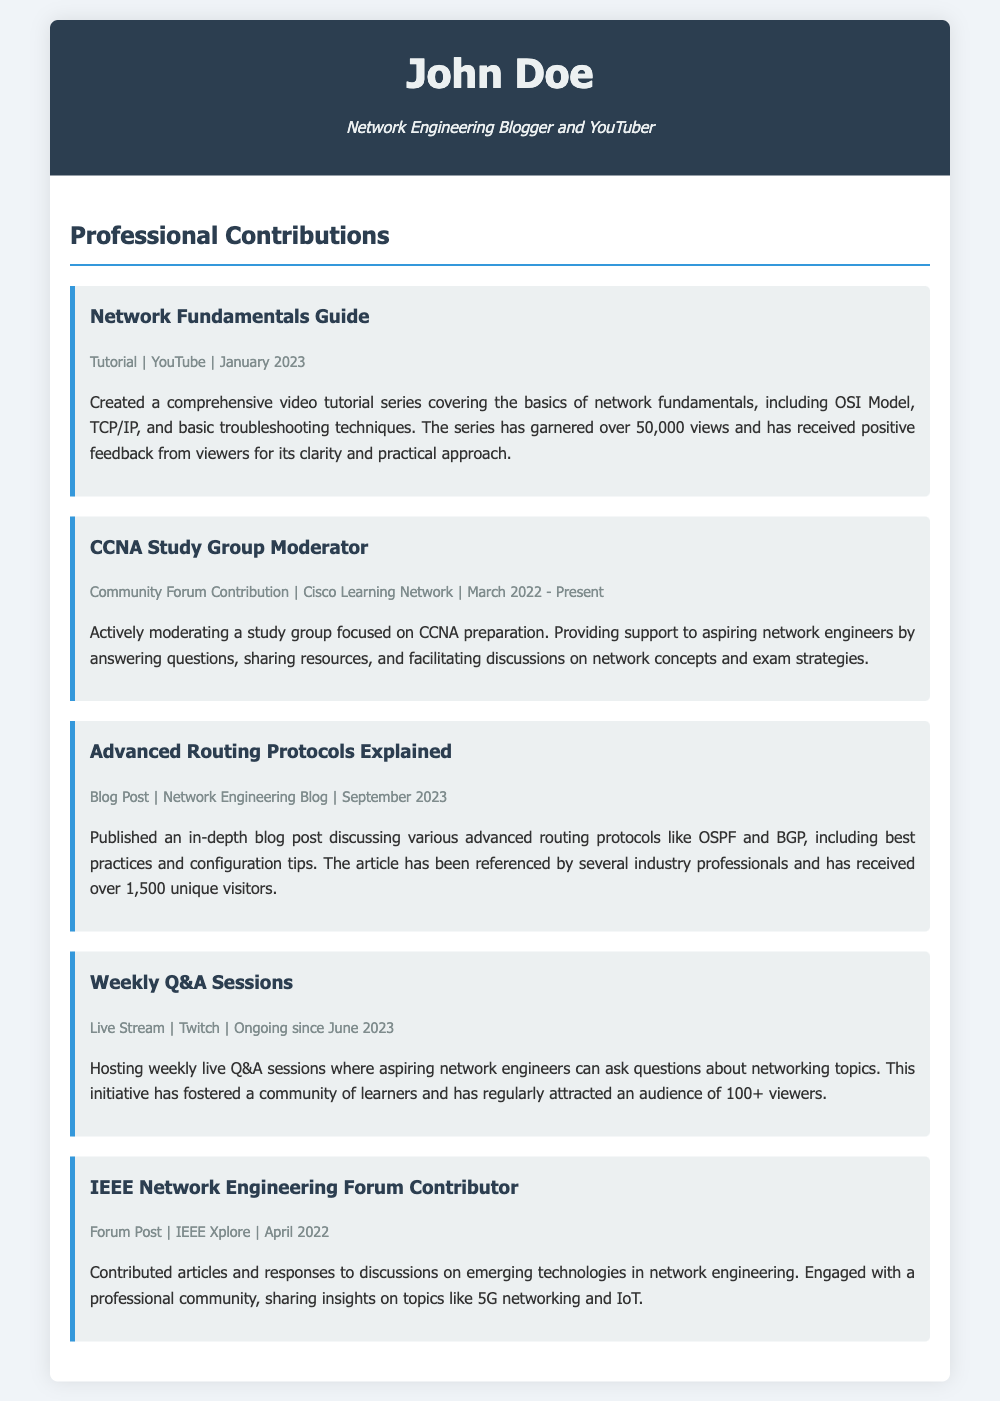What is the title of the video tutorial series created by John Doe? The title of the video tutorial series is "Network Fundamentals Guide" covering basics of network fundamentals.
Answer: Network Fundamentals Guide In which month and year did John Doe become a CCNA Study Group Moderator? John Doe became a CCNA Study Group Moderator in March 2022, as indicated in the document.
Answer: March 2022 How many unique visitors did the blog post on advanced routing protocols receive? The blog post "Advanced Routing Protocols Explained" received over 1,500 unique visitors.
Answer: 1,500 What streaming platform does John Doe use for his weekly Q&A sessions? The live Q&A sessions are hosted on Twitch, as mentioned in the contributions.
Answer: Twitch How many views did the "Network Fundamentals Guide" series garner? The series has garnered over 50,000 views according to the description of the contribution.
Answer: 50,000 Which advanced networking topics are discussed in the blog post by John Doe? The blog post discusses OSPF and BGP, which are advanced routing protocols.
Answer: OSPF and BGP Since when has John Doe been hosting weekly Q&A sessions? John Doe has been hosting weekly Q&A sessions since June 2023, based on the document timeframe.
Answer: June 2023 What type of community contributions does John Doe make as a contributor to the IEEE Network Engineering Forum? John Doe contributes articles and responses on emerging technologies in network engineering.
Answer: Articles and responses How has John Doe facilitated discussions in his CCNA Study Group? John Doe facilitates discussions by answering questions and sharing resources.
Answer: Answering questions and sharing resources 